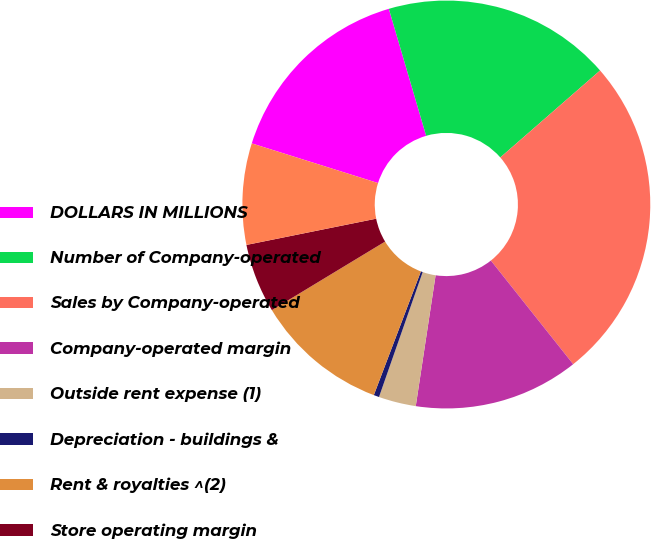Convert chart. <chart><loc_0><loc_0><loc_500><loc_500><pie_chart><fcel>DOLLARS IN MILLIONS<fcel>Number of Company-operated<fcel>Sales by Company-operated<fcel>Company-operated margin<fcel>Outside rent expense (1)<fcel>Depreciation - buildings &<fcel>Rent & royalties ^(2)<fcel>Store operating margin<fcel>Brand/real estate margin<nl><fcel>15.61%<fcel>18.14%<fcel>25.73%<fcel>13.08%<fcel>2.96%<fcel>0.43%<fcel>10.55%<fcel>5.49%<fcel>8.02%<nl></chart> 